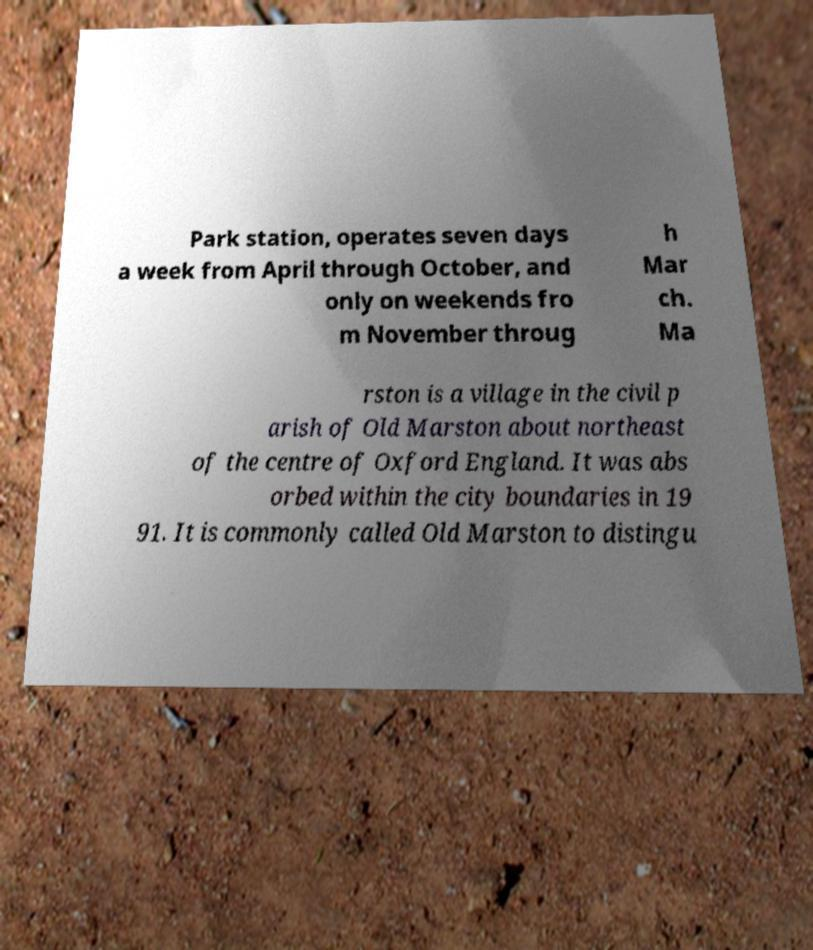Please identify and transcribe the text found in this image. Park station, operates seven days a week from April through October, and only on weekends fro m November throug h Mar ch. Ma rston is a village in the civil p arish of Old Marston about northeast of the centre of Oxford England. It was abs orbed within the city boundaries in 19 91. It is commonly called Old Marston to distingu 